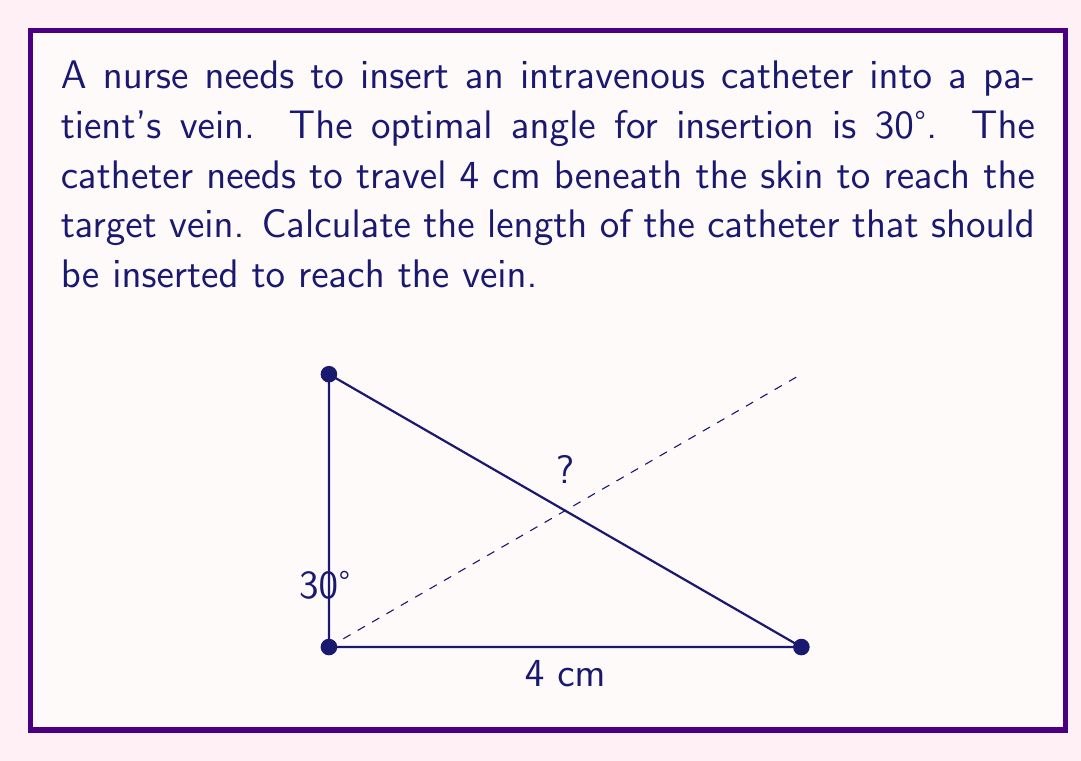Can you answer this question? To solve this problem, we can use trigonometry, specifically the sine function. Let's break it down step-by-step:

1) In a right-angled triangle, the sine of an angle is the ratio of the opposite side to the hypotenuse.

   $\sin(\theta) = \frac{\text{opposite}}{\text{hypotenuse}}$

2) In our case, we know the angle (30°) and the opposite side (4 cm). We want to find the hypotenuse, which is the length of the catheter.

3) Let's call the length of the catheter $x$. We can set up the equation:

   $\sin(30°) = \frac{4}{x}$

4) We know that $\sin(30°) = \frac{1}{2}$, so our equation becomes:

   $\frac{1}{2} = \frac{4}{x}$

5) To solve for $x$, we cross-multiply:

   $x \cdot \frac{1}{2} = 4$

6) Multiply both sides by 2:

   $x = 4 \cdot 2 = 8$

Therefore, the catheter should be 8 cm long to reach the vein when inserted at a 30° angle and traveling 4 cm beneath the skin.
Answer: The length of the catheter should be 8 cm. 